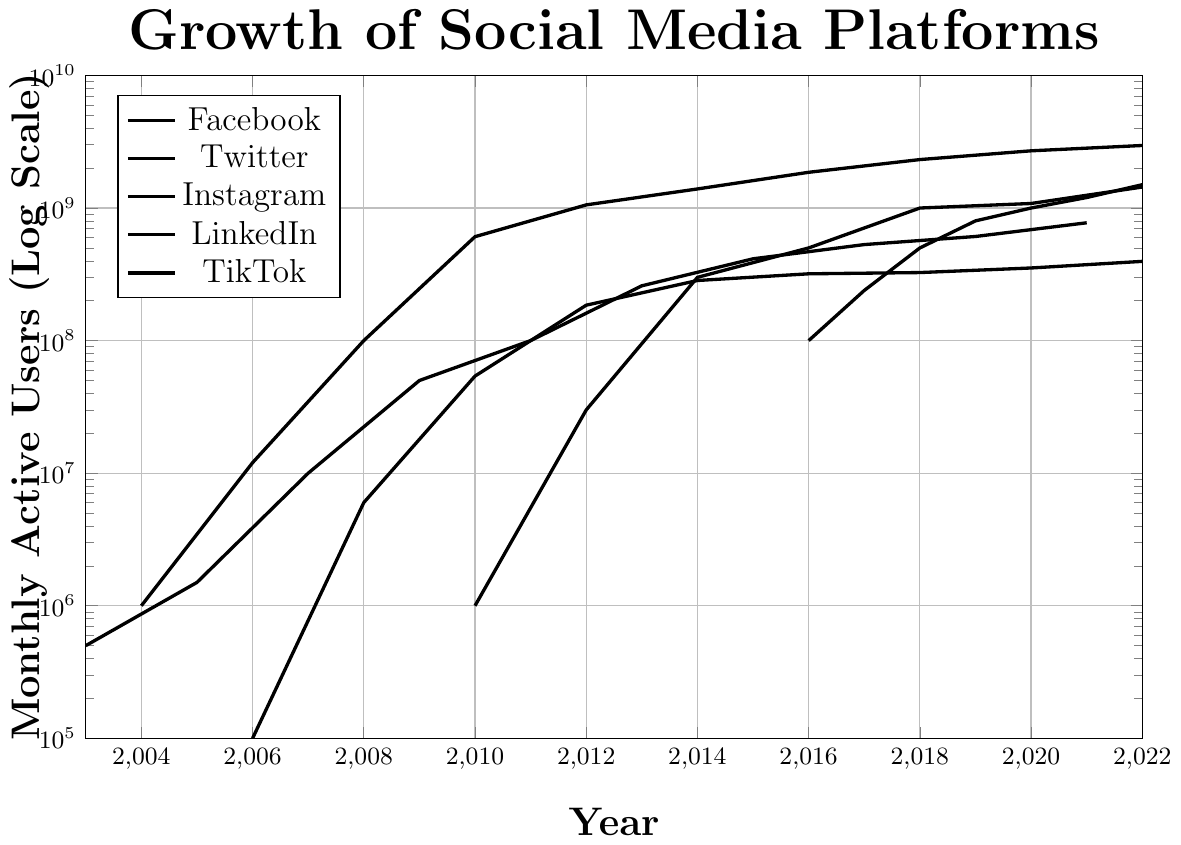What is the overall trend in Facebook's monthly active users from 2004 to 2022? Facebook's monthly active users show a consistent upward trend from 2004 to 2022, with the user base growing from 1 million to over 2.9 billion. The log scale helps to observe the exponential growth over the years.
Answer: Consistent upward trend How does TikTok's user growth between 2016 and 2022 compare to Instagram's growth in the same period? TikTok started with 100 million users in 2016 and grew to 1.5 billion by 2022, showing rapid growth. Comparatively, Instagram had 500 million users in 2016 and increased to 1.44 billion by 2022. TikTok's growth rate is faster, with a larger increase in users over the same period.
Answer: TikTok's growth rate is faster Which social media platform had the highest number of monthly active users in 2012? The figure shows that Facebook had the highest number of monthly active users in 2012, reaching 1.056 billion.
Answer: Facebook Compare the initial stages of growth (first two data points) for Twitter and LinkedIn. Which platform had a faster initial growth rate? Twitter grew from 100,000 users in 2006 to 6 million by 2008, while LinkedIn grew from 500,000 users in 2003 to 1.5 million by 2005. Calculating the growth ratios, Twitter's initial growth rate was faster (60x in two years for Twitter vs. 3x in two years for LinkedIn).
Answer: Twitter Between 2010 and 2014, which platform experienced the largest absolute increase in monthly active users? From the figure, Facebook increased from 608 million in 2010 to 1.393 billion in 2014, an increase of approximately 785 million users. This is the largest absolute increase compared to other platforms during the same period.
Answer: Facebook What are the color codes used to represent Facebook and Twitter in the plot? The plot uses blue to represent Facebook and red to represent Twitter, as indicated in the legend.
Answer: Blue for Facebook, Red for Twitter How many platforms surpassed 1 billion monthly active users by 2022? By 2022, Facebook, Instagram, and TikTok each have surpassed 1 billion monthly active users as shown on the plot.
Answer: Three platforms What is the difference in monthly active users between TikTok and LinkedIn in 2022? In 2022, TikTok had 1.5 billion users while LinkedIn had 774 million users. The difference is 1.5 billion - 774 million = 726 million users.
Answer: 726 million Which platform, among LinkedIn and Instagram, had more monthly active users in the year 2016? In 2016, Instagram had 500 million users and LinkedIn had 414 million. Thus, Instagram had more users.
Answer: Instagram By how much did Facebook's monthly active users increase from 2008 to 2010? From the plot, Facebook's users grew from 100 million in 2008 to 608 million in 2010. The increase is 608 million - 100 million = 508 million users.
Answer: 508 million 